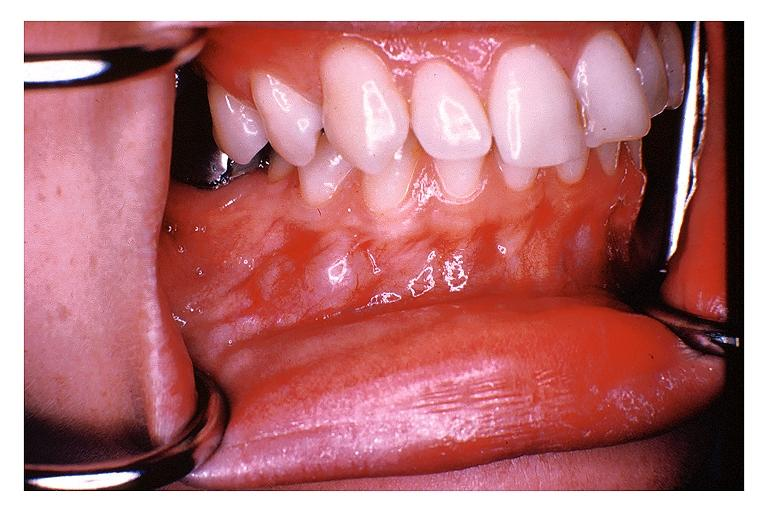does this image show traumatic neuroma?
Answer the question using a single word or phrase. Yes 